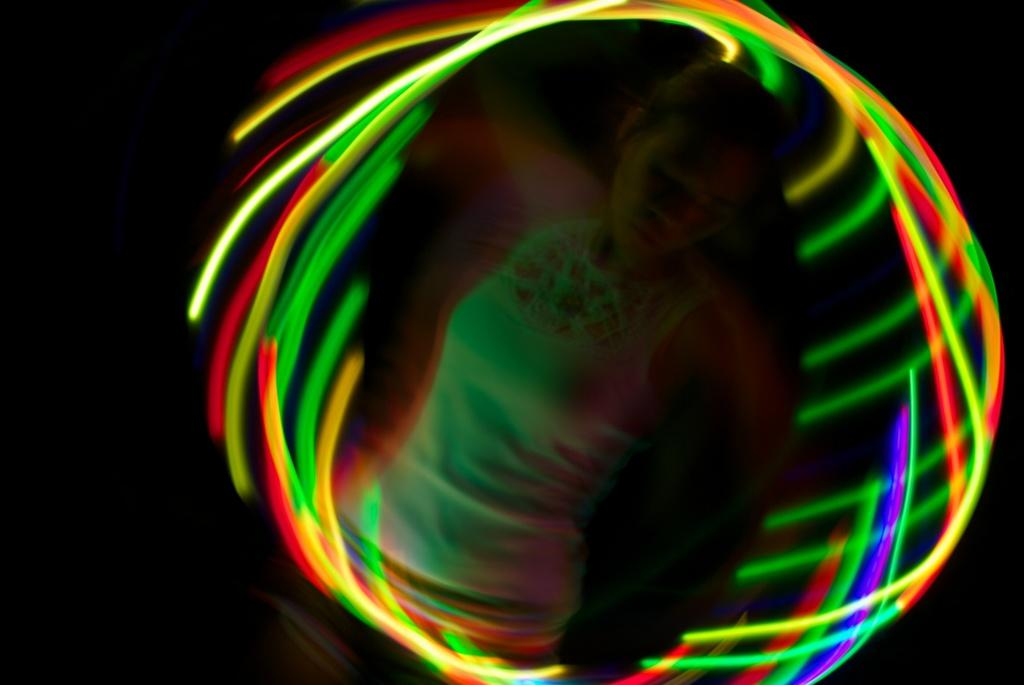What is the main feature of the image? There are colorful lights in the shape of a circle in the image. Can you describe the woman in the background? The woman is in the background of the image, but no specific details about her are provided. How would you describe the overall setting of the image? The background is dark, which may suggest a nighttime scene or a dimly lit area. What flavor of ice cream does the woman's brother prefer in the image? There is no mention of ice cream, a woman's brother, or any flavors in the image. 